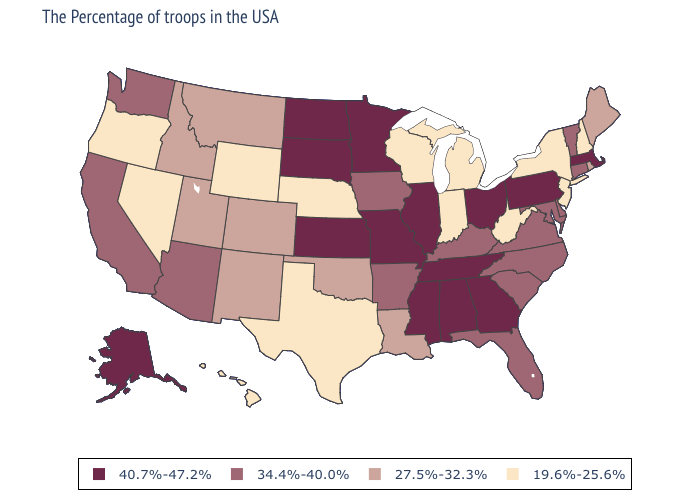What is the value of New York?
Concise answer only. 19.6%-25.6%. Does Washington have the same value as Tennessee?
Quick response, please. No. Does New Jersey have the highest value in the USA?
Short answer required. No. Among the states that border Connecticut , does Massachusetts have the lowest value?
Quick response, please. No. Does Louisiana have the same value as Minnesota?
Short answer required. No. Among the states that border Vermont , which have the highest value?
Be succinct. Massachusetts. Name the states that have a value in the range 27.5%-32.3%?
Write a very short answer. Maine, Rhode Island, Louisiana, Oklahoma, Colorado, New Mexico, Utah, Montana, Idaho. Name the states that have a value in the range 27.5%-32.3%?
Short answer required. Maine, Rhode Island, Louisiana, Oklahoma, Colorado, New Mexico, Utah, Montana, Idaho. Name the states that have a value in the range 34.4%-40.0%?
Concise answer only. Vermont, Connecticut, Delaware, Maryland, Virginia, North Carolina, South Carolina, Florida, Kentucky, Arkansas, Iowa, Arizona, California, Washington. What is the value of New Hampshire?
Short answer required. 19.6%-25.6%. How many symbols are there in the legend?
Short answer required. 4. What is the value of Hawaii?
Concise answer only. 19.6%-25.6%. What is the highest value in the USA?
Give a very brief answer. 40.7%-47.2%. What is the value of Nevada?
Concise answer only. 19.6%-25.6%. What is the highest value in states that border North Dakota?
Answer briefly. 40.7%-47.2%. 